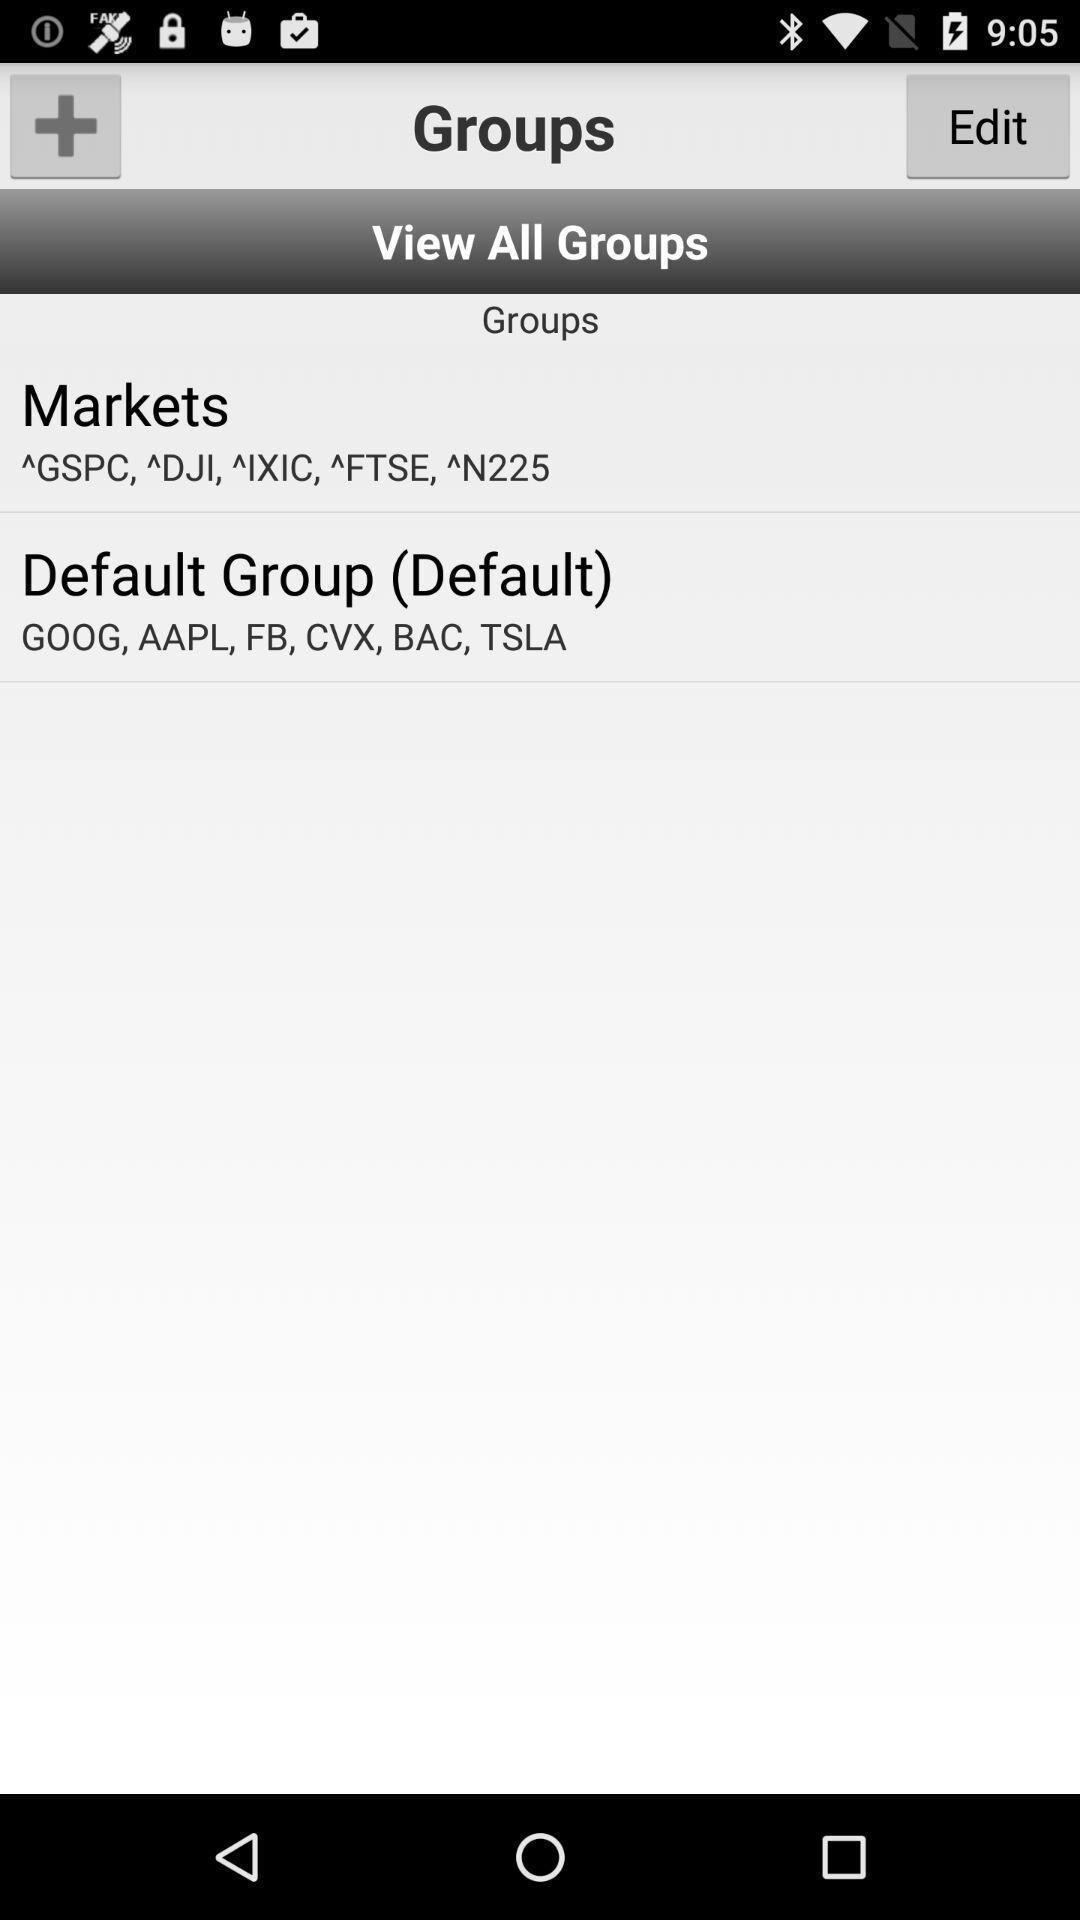Provide a detailed account of this screenshot. Screen page of a stocks tracking app. 